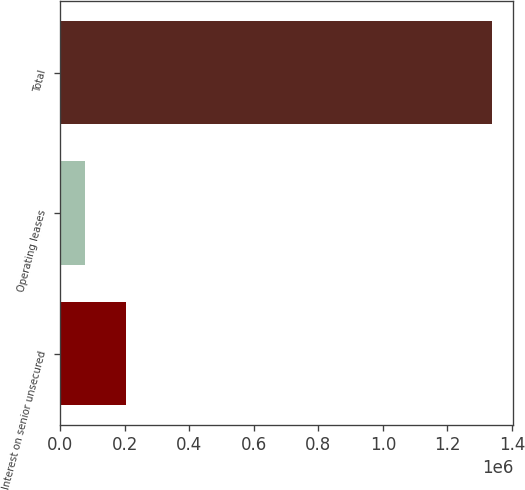<chart> <loc_0><loc_0><loc_500><loc_500><bar_chart><fcel>Interest on senior unsecured<fcel>Operating leases<fcel>Total<nl><fcel>203962<fcel>78112<fcel>1.33661e+06<nl></chart> 